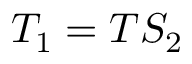<formula> <loc_0><loc_0><loc_500><loc_500>T _ { 1 } = T S _ { 2 }</formula> 